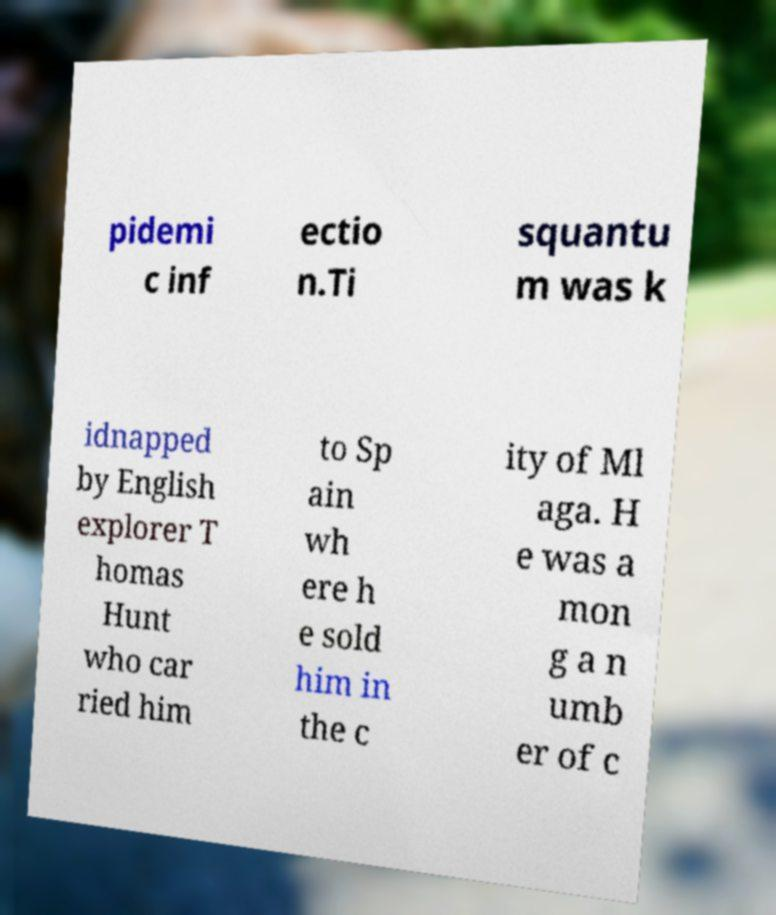There's text embedded in this image that I need extracted. Can you transcribe it verbatim? pidemi c inf ectio n.Ti squantu m was k idnapped by English explorer T homas Hunt who car ried him to Sp ain wh ere h e sold him in the c ity of Ml aga. H e was a mon g a n umb er of c 